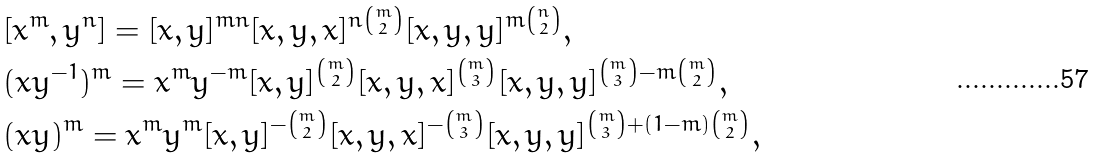<formula> <loc_0><loc_0><loc_500><loc_500>& [ x ^ { m } , y ^ { n } ] = [ x , y ] ^ { m n } [ x , y , x ] ^ { n { m \choose 2 } } [ x , y , y ] ^ { m { n \choose 2 } } , \\ & ( x y ^ { - 1 } ) ^ { m } = x ^ { m } y ^ { - m } [ x , y ] ^ { m \choose 2 } [ x , y , x ] ^ { m \choose 3 } [ x , y , y ] ^ { { m \choose 3 } - m { m \choose 2 } } , \\ & ( x y ) ^ { m } = x ^ { m } y ^ { m } [ x , y ] ^ { - { m \choose 2 } } [ x , y , x ] ^ { - { m \choose 3 } } [ x , y , y ] ^ { { m \choose 3 } + ( 1 - m ) { m \choose 2 } } ,</formula> 